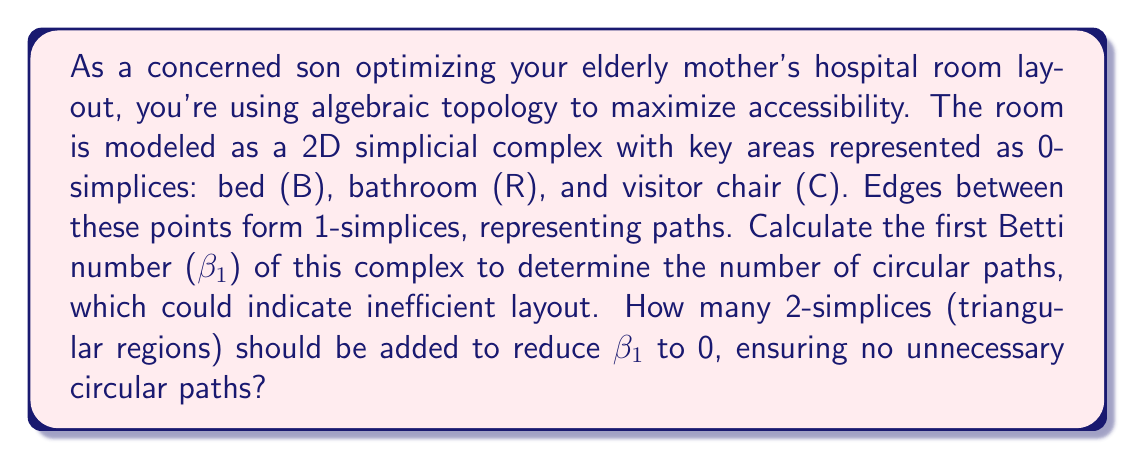Provide a solution to this math problem. Let's approach this step-by-step:

1) First, let's understand the initial simplicial complex:
   - 0-simplices (vertices): B, R, C (3 in total)
   - 1-simplices (edges): BR, RC, CB (3 in total)
   - 2-simplices (triangles): Initially 0

2) Calculate the initial Betti numbers:
   - $\beta_0$ = number of connected components = 1
   - $\beta_1$ = number of holes = 1 (the triangle BRC forms a hole)
   - $\beta_2$ = number of voids = 0 (no 3D structure)

3) The goal is to reduce $\beta_1$ to 0. This can be done by filling the hole with a 2-simplex.

4) Adding one 2-simplex (triangle BRC) will:
   - Increase the number of 2-simplices by 1
   - Keep the number of 1-simplices and 0-simplices the same
   - Fill the hole, reducing $\beta_1$ to 0

5) After adding the 2-simplex:
   - $\beta_0$ = 1 (still one connected component)
   - $\beta_1$ = 0 (no more holes)
   - $\beta_2$ = 0 (still no 3D structure)

Therefore, adding one 2-simplex (triangular region) will reduce $\beta_1$ to 0, ensuring no unnecessary circular paths in the room layout.
Answer: 1 